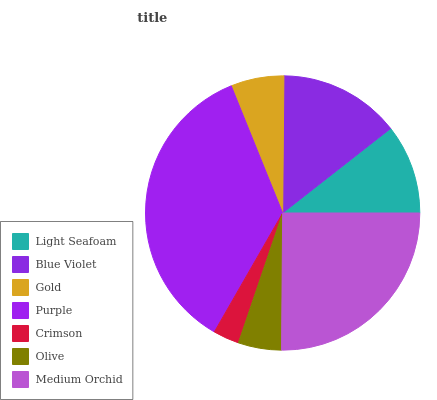Is Crimson the minimum?
Answer yes or no. Yes. Is Purple the maximum?
Answer yes or no. Yes. Is Blue Violet the minimum?
Answer yes or no. No. Is Blue Violet the maximum?
Answer yes or no. No. Is Blue Violet greater than Light Seafoam?
Answer yes or no. Yes. Is Light Seafoam less than Blue Violet?
Answer yes or no. Yes. Is Light Seafoam greater than Blue Violet?
Answer yes or no. No. Is Blue Violet less than Light Seafoam?
Answer yes or no. No. Is Light Seafoam the high median?
Answer yes or no. Yes. Is Light Seafoam the low median?
Answer yes or no. Yes. Is Crimson the high median?
Answer yes or no. No. Is Gold the low median?
Answer yes or no. No. 